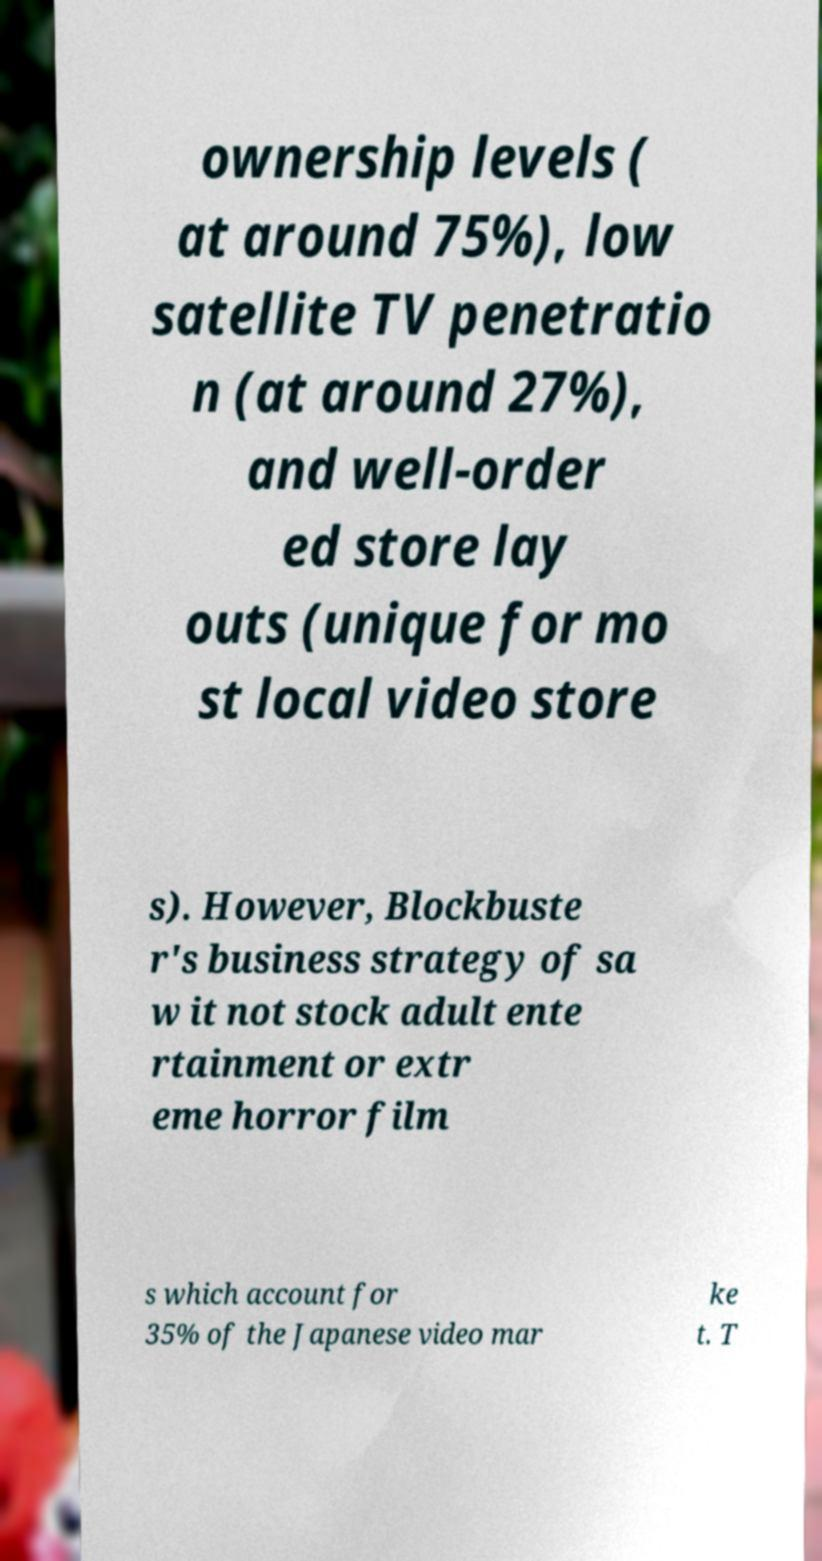Could you assist in decoding the text presented in this image and type it out clearly? ownership levels ( at around 75%), low satellite TV penetratio n (at around 27%), and well-order ed store lay outs (unique for mo st local video store s). However, Blockbuste r's business strategy of sa w it not stock adult ente rtainment or extr eme horror film s which account for 35% of the Japanese video mar ke t. T 